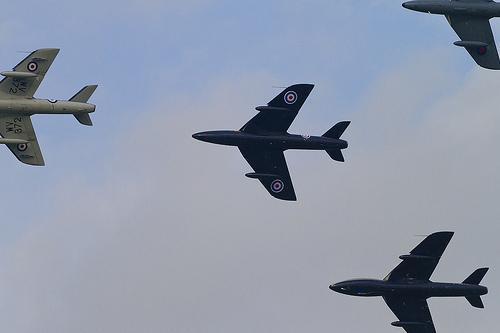How many planes can be completely seen?
Give a very brief answer. 1. How many planes are there?
Give a very brief answer. 4. How many targets are on the wings?
Give a very brief answer. 4. How many planes are gray?
Give a very brief answer. 1. How many jets are shown?
Give a very brief answer. 4. How many wings are shown?
Give a very brief answer. 7. How many planes are in the photo?
Give a very brief answer. 4. 